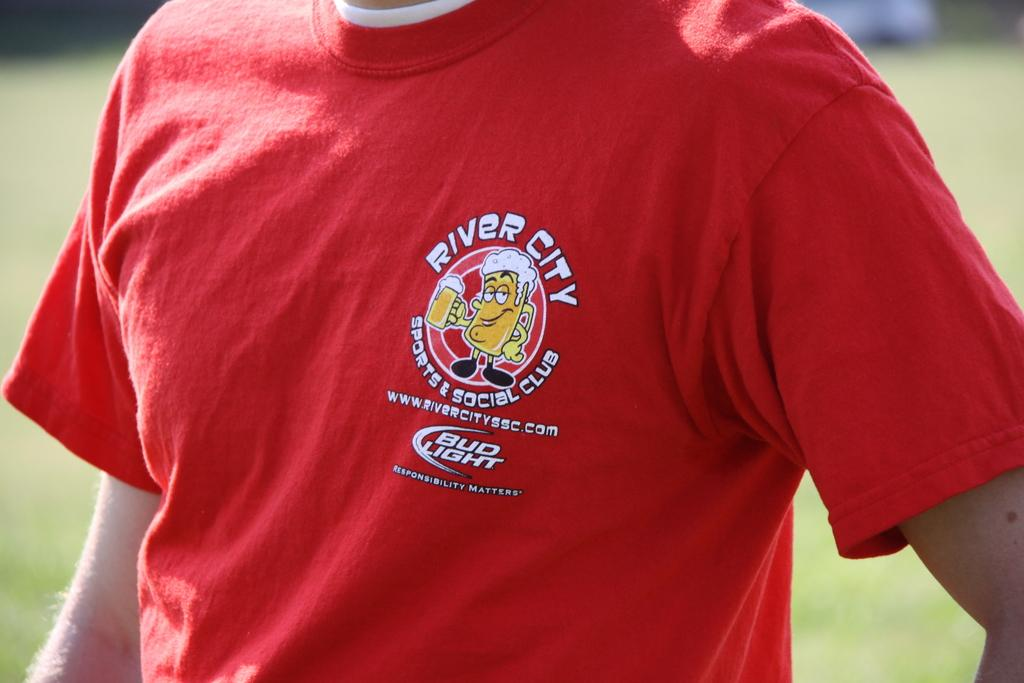<image>
Offer a succinct explanation of the picture presented. A man is wearing a red shirt sponsored by Bud Light. 